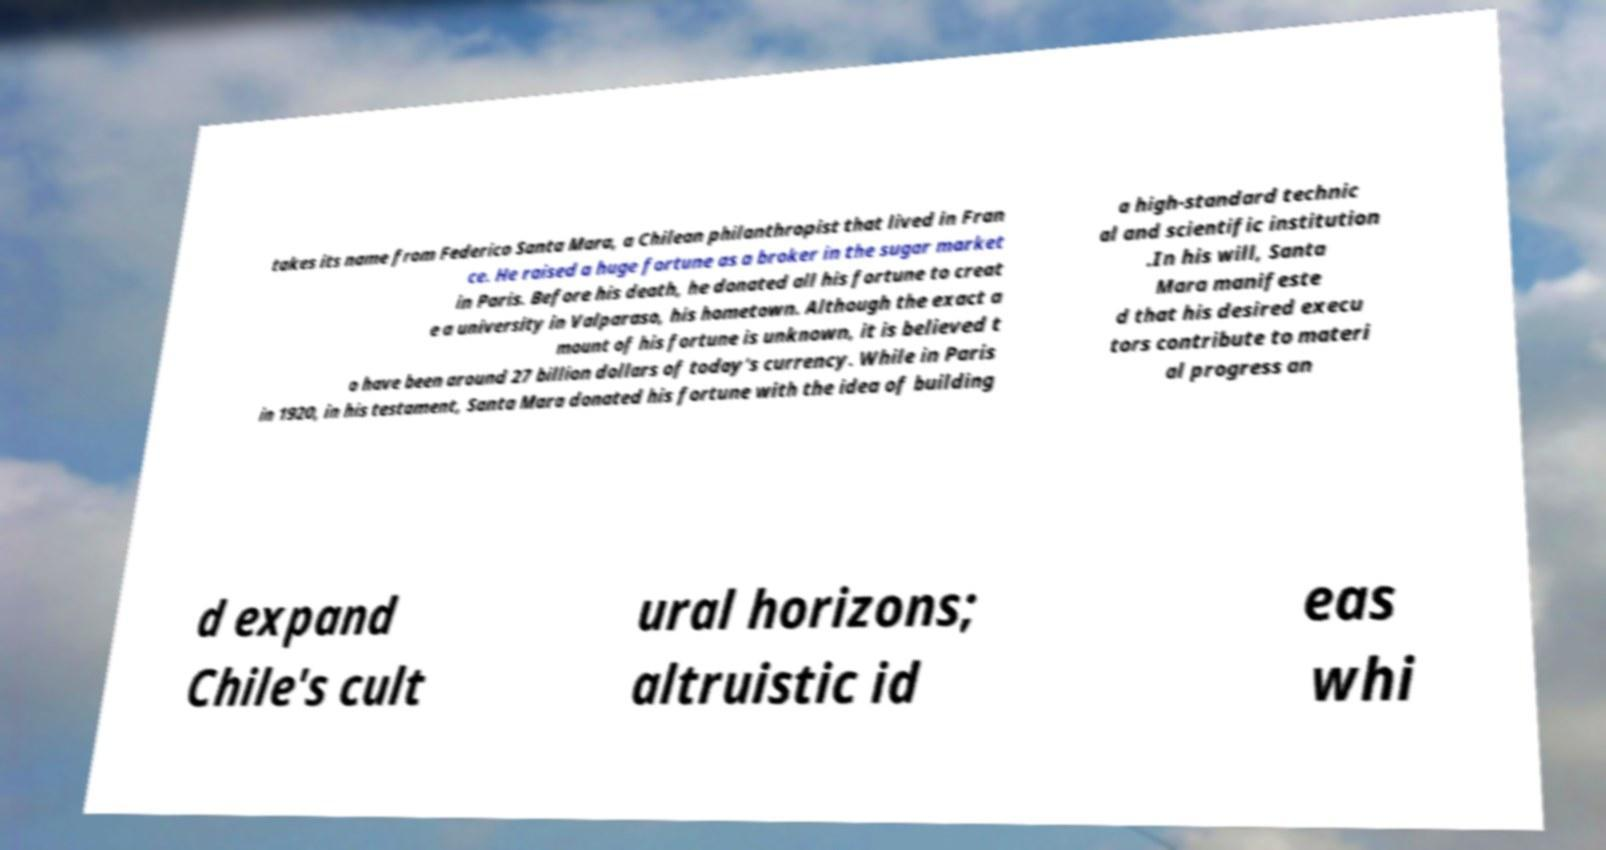Could you assist in decoding the text presented in this image and type it out clearly? takes its name from Federico Santa Mara, a Chilean philanthropist that lived in Fran ce. He raised a huge fortune as a broker in the sugar market in Paris. Before his death, he donated all his fortune to creat e a university in Valparaso, his hometown. Although the exact a mount of his fortune is unknown, it is believed t o have been around 27 billion dollars of today's currency. While in Paris in 1920, in his testament, Santa Mara donated his fortune with the idea of building a high-standard technic al and scientific institution .In his will, Santa Mara manifeste d that his desired execu tors contribute to materi al progress an d expand Chile's cult ural horizons; altruistic id eas whi 